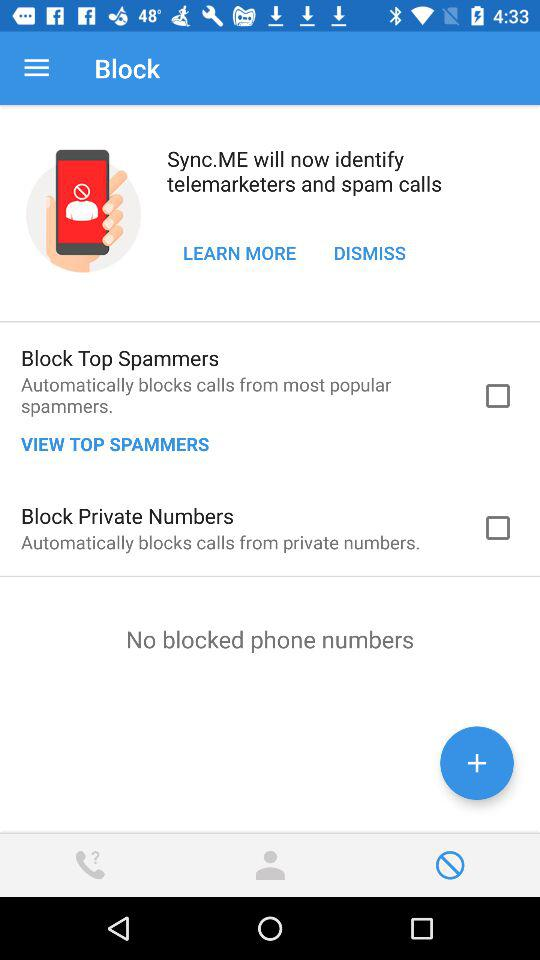Who are the new contacts?
When the provided information is insufficient, respond with <no answer>. <no answer> 